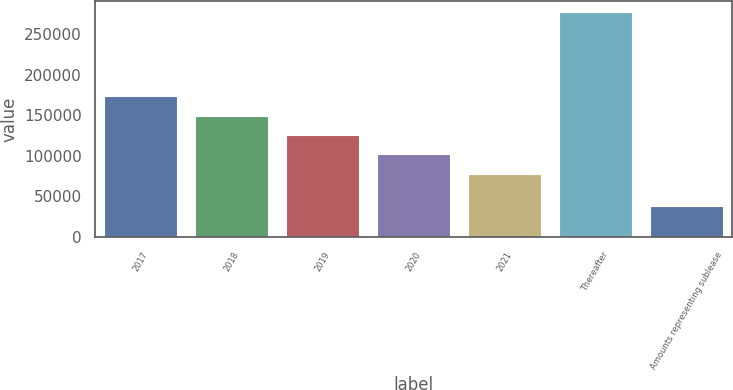Convert chart. <chart><loc_0><loc_0><loc_500><loc_500><bar_chart><fcel>2017<fcel>2018<fcel>2019<fcel>2020<fcel>2021<fcel>Thereafter<fcel>Amounts representing sublease<nl><fcel>173382<fcel>149483<fcel>125585<fcel>101686<fcel>77788<fcel>277385<fcel>38401<nl></chart> 